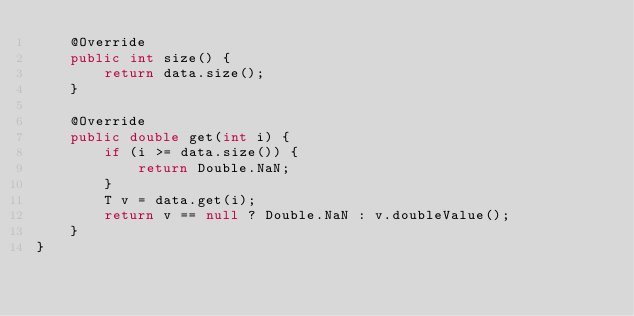Convert code to text. <code><loc_0><loc_0><loc_500><loc_500><_Java_>    @Override
    public int size() {
        return data.size();
    }

    @Override
    public double get(int i) {
        if (i >= data.size()) {
            return Double.NaN;
        }
        T v = data.get(i);
        return v == null ? Double.NaN : v.doubleValue();
    }
}
</code> 